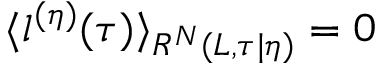Convert formula to latex. <formula><loc_0><loc_0><loc_500><loc_500>\langle l ^ { ( \eta ) } ( \tau ) \rangle _ { R ^ { N } ( L , \tau | \eta ) } = 0</formula> 